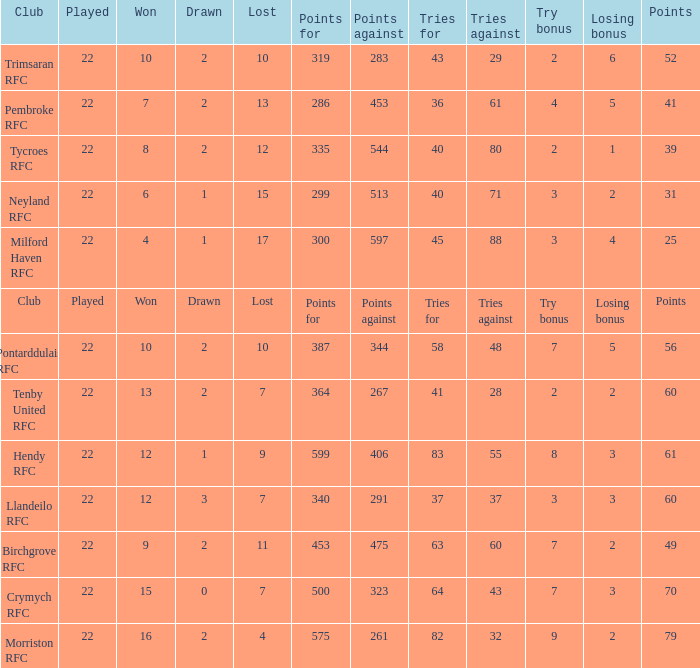What's the won with try bonus being 8 12.0. 